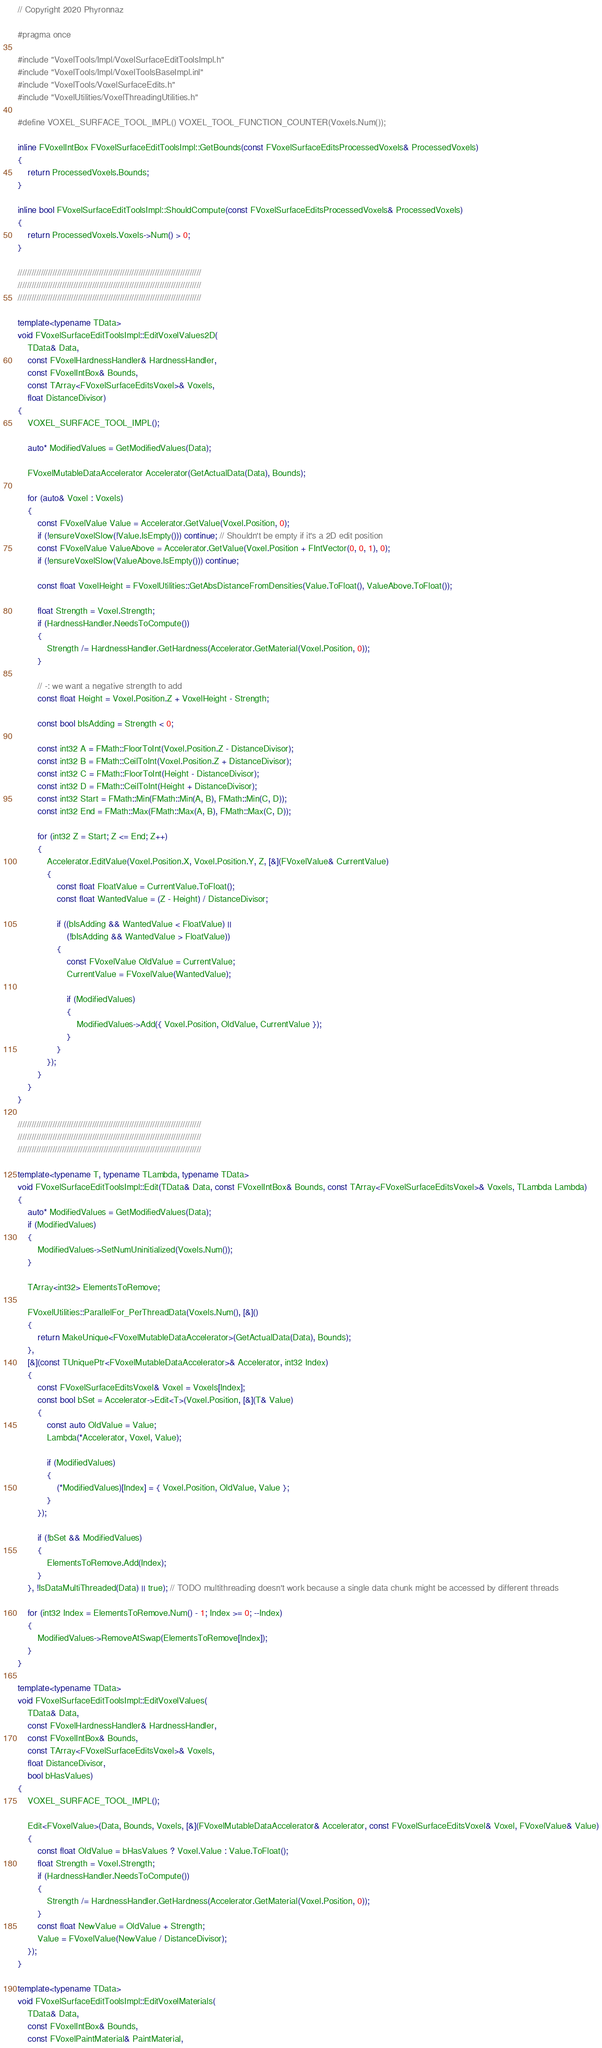<code> <loc_0><loc_0><loc_500><loc_500><_C++_>// Copyright 2020 Phyronnaz

#pragma once

#include "VoxelTools/Impl/VoxelSurfaceEditToolsImpl.h"
#include "VoxelTools/Impl/VoxelToolsBaseImpl.inl"
#include "VoxelTools/VoxelSurfaceEdits.h"
#include "VoxelUtilities/VoxelThreadingUtilities.h"

#define VOXEL_SURFACE_TOOL_IMPL() VOXEL_TOOL_FUNCTION_COUNTER(Voxels.Num());

inline FVoxelIntBox FVoxelSurfaceEditToolsImpl::GetBounds(const FVoxelSurfaceEditsProcessedVoxels& ProcessedVoxels)
{
	return ProcessedVoxels.Bounds;
}

inline bool FVoxelSurfaceEditToolsImpl::ShouldCompute(const FVoxelSurfaceEditsProcessedVoxels& ProcessedVoxels)
{
	return ProcessedVoxels.Voxels->Num() > 0;
}

///////////////////////////////////////////////////////////////////////////////
///////////////////////////////////////////////////////////////////////////////
///////////////////////////////////////////////////////////////////////////////

template<typename TData>
void FVoxelSurfaceEditToolsImpl::EditVoxelValues2D(
	TData& Data, 
	const FVoxelHardnessHandler& HardnessHandler, 
	const FVoxelIntBox& Bounds, 
	const TArray<FVoxelSurfaceEditsVoxel>& Voxels, 
	float DistanceDivisor)
{
	VOXEL_SURFACE_TOOL_IMPL();
	
	auto* ModifiedValues = GetModifiedValues(Data);
	
	FVoxelMutableDataAccelerator Accelerator(GetActualData(Data), Bounds);

	for (auto& Voxel : Voxels)
	{
		const FVoxelValue Value = Accelerator.GetValue(Voxel.Position, 0);
		if (!ensureVoxelSlow(!Value.IsEmpty())) continue; // Shouldn't be empty if it's a 2D edit position
		const FVoxelValue ValueAbove = Accelerator.GetValue(Voxel.Position + FIntVector(0, 0, 1), 0);
		if (!ensureVoxelSlow(ValueAbove.IsEmpty())) continue;

		const float VoxelHeight = FVoxelUtilities::GetAbsDistanceFromDensities(Value.ToFloat(), ValueAbove.ToFloat());
		
		float Strength = Voxel.Strength;
		if (HardnessHandler.NeedsToCompute())
		{
			Strength /= HardnessHandler.GetHardness(Accelerator.GetMaterial(Voxel.Position, 0));
		}

		// -: we want a negative strength to add
		const float Height = Voxel.Position.Z + VoxelHeight - Strength;

		const bool bIsAdding = Strength < 0;

		const int32 A = FMath::FloorToInt(Voxel.Position.Z - DistanceDivisor);
		const int32 B = FMath::CeilToInt(Voxel.Position.Z + DistanceDivisor);
		const int32 C = FMath::FloorToInt(Height - DistanceDivisor);
		const int32 D = FMath::CeilToInt(Height + DistanceDivisor);
		const int32 Start = FMath::Min(FMath::Min(A, B), FMath::Min(C, D));
		const int32 End = FMath::Max(FMath::Max(A, B), FMath::Max(C, D));

		for (int32 Z = Start; Z <= End; Z++)
		{
			Accelerator.EditValue(Voxel.Position.X, Voxel.Position.Y, Z, [&](FVoxelValue& CurrentValue)
			{
				const float FloatValue = CurrentValue.ToFloat();
				const float WantedValue = (Z - Height) / DistanceDivisor;

				if ((bIsAdding && WantedValue < FloatValue) ||
					(!bIsAdding && WantedValue > FloatValue))
				{
					const FVoxelValue OldValue = CurrentValue;
					CurrentValue = FVoxelValue(WantedValue);
					
					if (ModifiedValues)
					{
						ModifiedValues->Add({ Voxel.Position, OldValue, CurrentValue });
					}
				}
			});
		}
	}
}

///////////////////////////////////////////////////////////////////////////////
///////////////////////////////////////////////////////////////////////////////
///////////////////////////////////////////////////////////////////////////////

template<typename T, typename TLambda, typename TData>
void FVoxelSurfaceEditToolsImpl::Edit(TData& Data, const FVoxelIntBox& Bounds, const TArray<FVoxelSurfaceEditsVoxel>& Voxels, TLambda Lambda)
{
	auto* ModifiedValues = GetModifiedValues(Data);
	if (ModifiedValues)
	{
		ModifiedValues->SetNumUninitialized(Voxels.Num());
	}

	TArray<int32> ElementsToRemove;

	FVoxelUtilities::ParallelFor_PerThreadData(Voxels.Num(), [&]()
	{
		return MakeUnique<FVoxelMutableDataAccelerator>(GetActualData(Data), Bounds);
	}, 
	[&](const TUniquePtr<FVoxelMutableDataAccelerator>& Accelerator, int32 Index)
	{
		const FVoxelSurfaceEditsVoxel& Voxel = Voxels[Index];
		const bool bSet = Accelerator->Edit<T>(Voxel.Position, [&](T& Value)
		{
			const auto OldValue = Value;
			Lambda(*Accelerator, Voxel, Value);
			
			if (ModifiedValues)
			{
				(*ModifiedValues)[Index] = { Voxel.Position, OldValue, Value };
			}
		});

		if (!bSet && ModifiedValues)
		{
			ElementsToRemove.Add(Index);
		}
	}, !IsDataMultiThreaded(Data) || true); // TODO multithreading doesn't work because a single data chunk might be accessed by different threads

	for (int32 Index = ElementsToRemove.Num() - 1; Index >= 0; --Index)
	{
		ModifiedValues->RemoveAtSwap(ElementsToRemove[Index]);
	}
}

template<typename TData>
void FVoxelSurfaceEditToolsImpl::EditVoxelValues(
	TData& Data,
	const FVoxelHardnessHandler& HardnessHandler,
	const FVoxelIntBox& Bounds,
	const TArray<FVoxelSurfaceEditsVoxel>& Voxels,
	float DistanceDivisor,
	bool bHasValues)
{
	VOXEL_SURFACE_TOOL_IMPL();

	Edit<FVoxelValue>(Data, Bounds, Voxels, [&](FVoxelMutableDataAccelerator& Accelerator, const FVoxelSurfaceEditsVoxel& Voxel, FVoxelValue& Value)
	{
		const float OldValue = bHasValues ? Voxel.Value : Value.ToFloat();
		float Strength = Voxel.Strength;
		if (HardnessHandler.NeedsToCompute())
		{
			Strength /= HardnessHandler.GetHardness(Accelerator.GetMaterial(Voxel.Position, 0));
		}
		const float NewValue = OldValue + Strength;
		Value = FVoxelValue(NewValue / DistanceDivisor);
	});
}

template<typename TData>
void FVoxelSurfaceEditToolsImpl::EditVoxelMaterials(
	TData& Data, 
	const FVoxelIntBox& Bounds, 
	const FVoxelPaintMaterial& PaintMaterial, </code> 